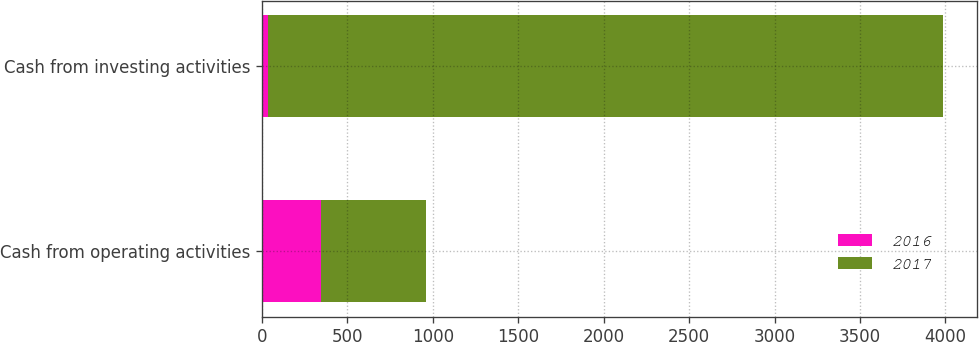Convert chart to OTSL. <chart><loc_0><loc_0><loc_500><loc_500><stacked_bar_chart><ecel><fcel>Cash from operating activities<fcel>Cash from investing activities<nl><fcel>2016<fcel>343<fcel>33<nl><fcel>2017<fcel>615<fcel>3952<nl></chart> 